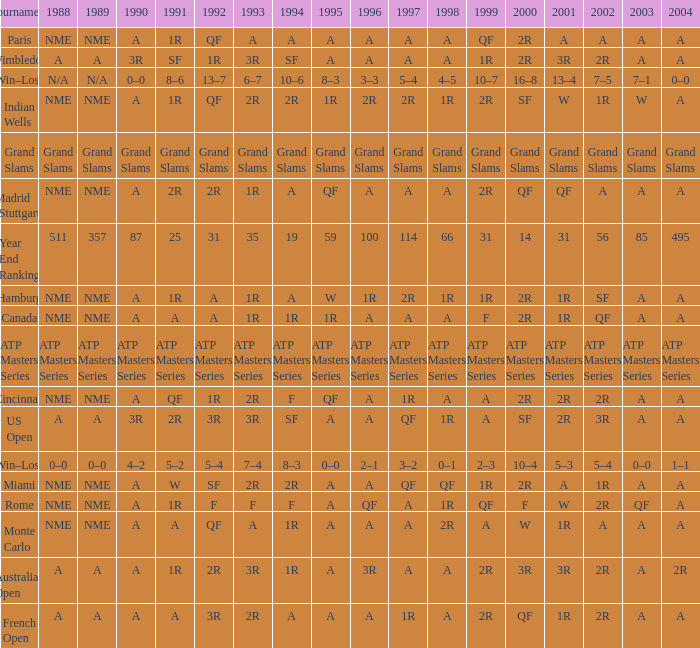What shows for 1988 when 1994 shows 10–6? N/A. 